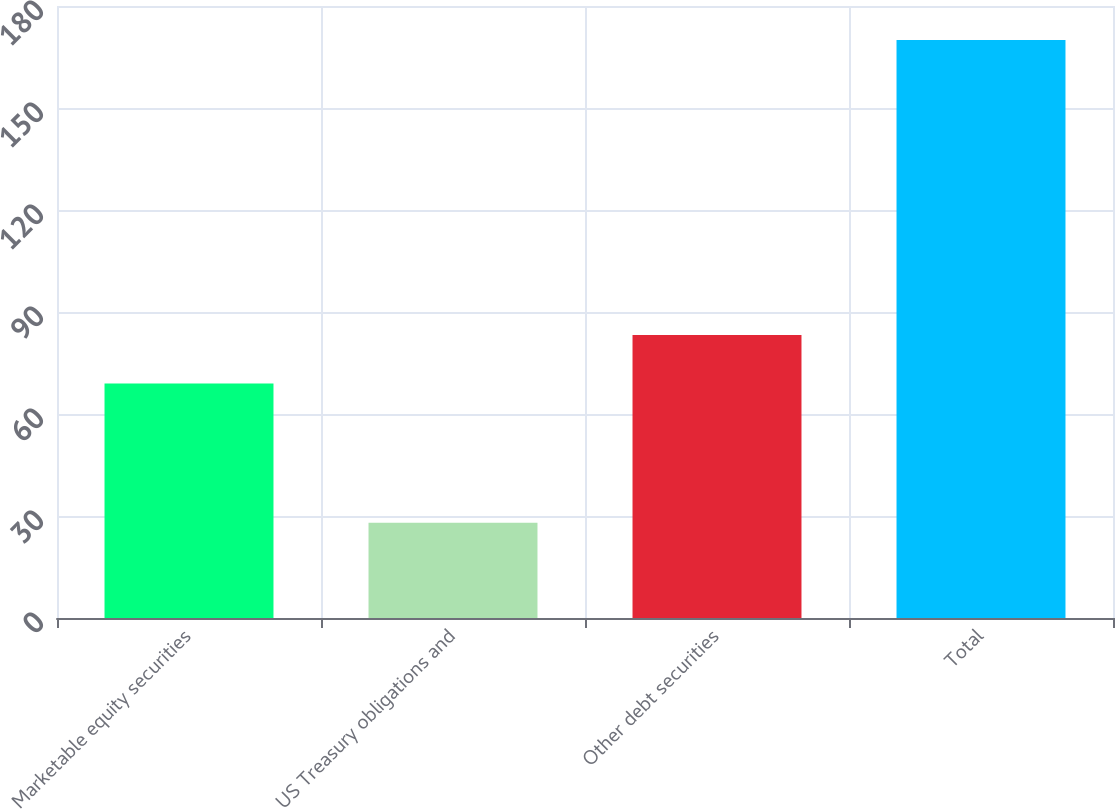<chart> <loc_0><loc_0><loc_500><loc_500><bar_chart><fcel>Marketable equity securities<fcel>US Treasury obligations and<fcel>Other debt securities<fcel>Total<nl><fcel>69<fcel>28<fcel>83.2<fcel>170<nl></chart> 